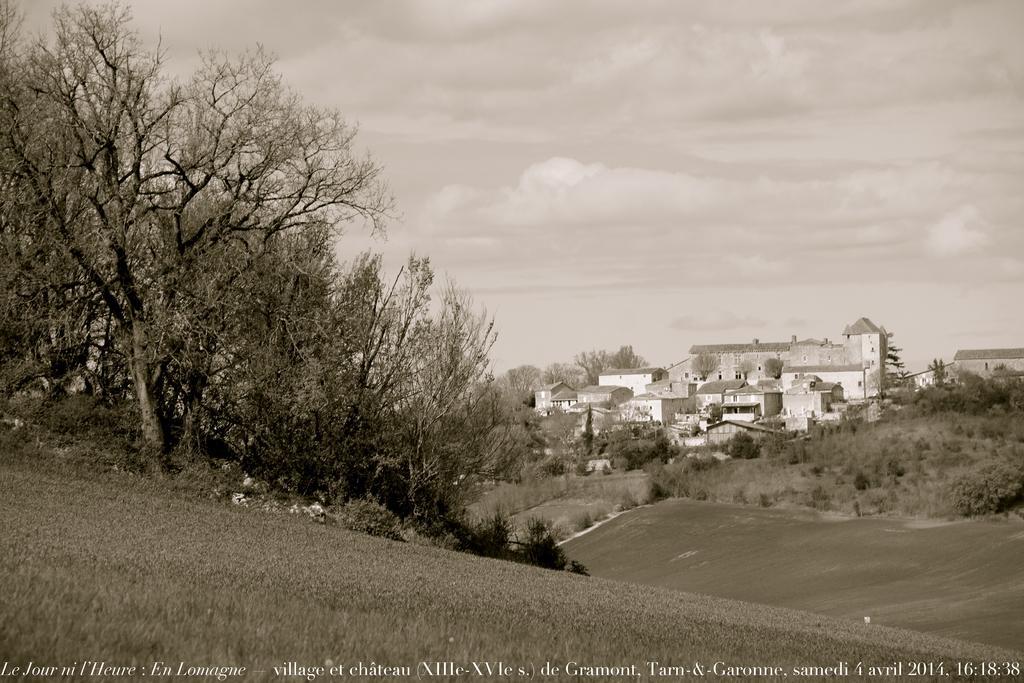Describe this image in one or two sentences. In this picture I can see the grass, few plants and number of trees in front and in the middle of this picture, I can see number of buildings. In the background I can see the sky. On the bottom side of this picture I see something is written. 